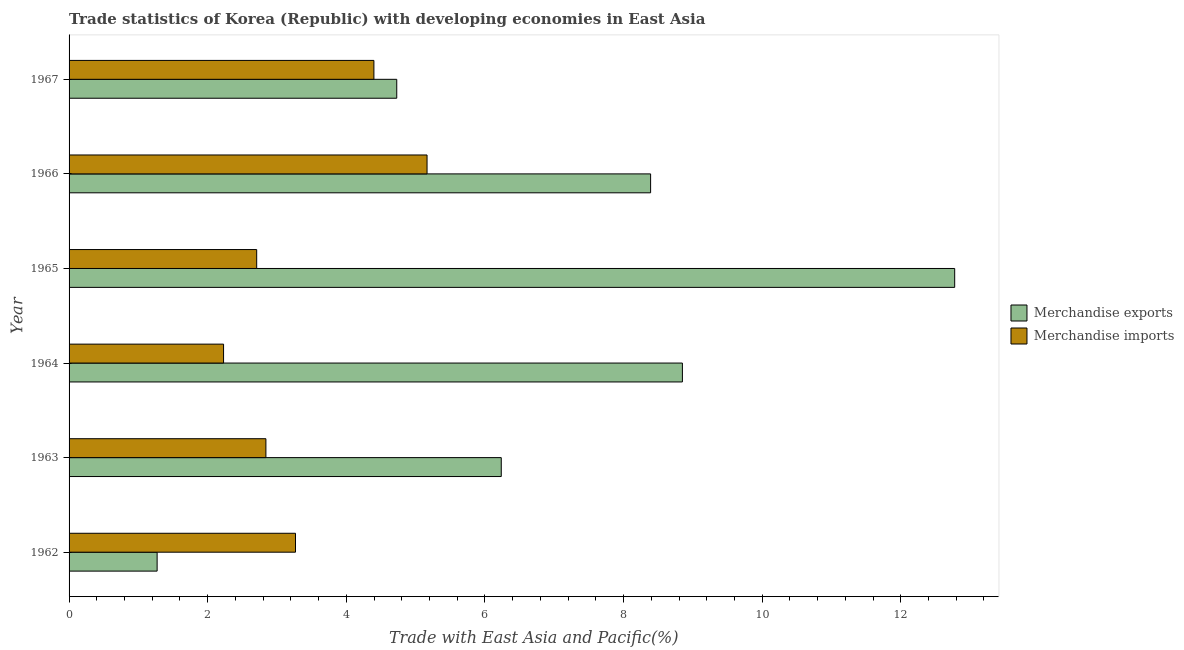How many different coloured bars are there?
Keep it short and to the point. 2. How many groups of bars are there?
Provide a succinct answer. 6. Are the number of bars per tick equal to the number of legend labels?
Offer a very short reply. Yes. Are the number of bars on each tick of the Y-axis equal?
Provide a short and direct response. Yes. What is the label of the 1st group of bars from the top?
Ensure brevity in your answer.  1967. What is the merchandise imports in 1962?
Provide a short and direct response. 3.27. Across all years, what is the maximum merchandise exports?
Offer a terse response. 12.78. Across all years, what is the minimum merchandise imports?
Provide a succinct answer. 2.23. In which year was the merchandise exports maximum?
Make the answer very short. 1965. In which year was the merchandise exports minimum?
Your answer should be compact. 1962. What is the total merchandise exports in the graph?
Provide a short and direct response. 42.25. What is the difference between the merchandise imports in 1962 and that in 1963?
Keep it short and to the point. 0.43. What is the difference between the merchandise imports in 1967 and the merchandise exports in 1963?
Provide a short and direct response. -1.84. What is the average merchandise exports per year?
Ensure brevity in your answer.  7.04. In the year 1965, what is the difference between the merchandise imports and merchandise exports?
Ensure brevity in your answer.  -10.07. What is the ratio of the merchandise imports in 1964 to that in 1965?
Your response must be concise. 0.82. Is the merchandise exports in 1963 less than that in 1964?
Your response must be concise. Yes. What is the difference between the highest and the second highest merchandise imports?
Your response must be concise. 0.77. What is the difference between the highest and the lowest merchandise exports?
Provide a short and direct response. 11.51. In how many years, is the merchandise exports greater than the average merchandise exports taken over all years?
Give a very brief answer. 3. What does the 1st bar from the bottom in 1967 represents?
Your answer should be compact. Merchandise exports. Are all the bars in the graph horizontal?
Provide a short and direct response. Yes. What is the difference between two consecutive major ticks on the X-axis?
Make the answer very short. 2. Are the values on the major ticks of X-axis written in scientific E-notation?
Keep it short and to the point. No. Does the graph contain grids?
Ensure brevity in your answer.  No. Where does the legend appear in the graph?
Provide a succinct answer. Center right. How are the legend labels stacked?
Your answer should be compact. Vertical. What is the title of the graph?
Offer a terse response. Trade statistics of Korea (Republic) with developing economies in East Asia. Does "Excluding technical cooperation" appear as one of the legend labels in the graph?
Your answer should be compact. No. What is the label or title of the X-axis?
Make the answer very short. Trade with East Asia and Pacific(%). What is the label or title of the Y-axis?
Your response must be concise. Year. What is the Trade with East Asia and Pacific(%) of Merchandise exports in 1962?
Your answer should be compact. 1.27. What is the Trade with East Asia and Pacific(%) in Merchandise imports in 1962?
Your response must be concise. 3.27. What is the Trade with East Asia and Pacific(%) in Merchandise exports in 1963?
Offer a very short reply. 6.24. What is the Trade with East Asia and Pacific(%) in Merchandise imports in 1963?
Offer a terse response. 2.84. What is the Trade with East Asia and Pacific(%) of Merchandise exports in 1964?
Keep it short and to the point. 8.85. What is the Trade with East Asia and Pacific(%) in Merchandise imports in 1964?
Give a very brief answer. 2.23. What is the Trade with East Asia and Pacific(%) in Merchandise exports in 1965?
Give a very brief answer. 12.78. What is the Trade with East Asia and Pacific(%) in Merchandise imports in 1965?
Keep it short and to the point. 2.71. What is the Trade with East Asia and Pacific(%) of Merchandise exports in 1966?
Keep it short and to the point. 8.39. What is the Trade with East Asia and Pacific(%) in Merchandise imports in 1966?
Offer a terse response. 5.16. What is the Trade with East Asia and Pacific(%) in Merchandise exports in 1967?
Offer a very short reply. 4.73. What is the Trade with East Asia and Pacific(%) in Merchandise imports in 1967?
Your answer should be compact. 4.4. Across all years, what is the maximum Trade with East Asia and Pacific(%) in Merchandise exports?
Ensure brevity in your answer.  12.78. Across all years, what is the maximum Trade with East Asia and Pacific(%) in Merchandise imports?
Offer a terse response. 5.16. Across all years, what is the minimum Trade with East Asia and Pacific(%) in Merchandise exports?
Offer a very short reply. 1.27. Across all years, what is the minimum Trade with East Asia and Pacific(%) in Merchandise imports?
Offer a terse response. 2.23. What is the total Trade with East Asia and Pacific(%) of Merchandise exports in the graph?
Offer a terse response. 42.25. What is the total Trade with East Asia and Pacific(%) of Merchandise imports in the graph?
Offer a terse response. 20.61. What is the difference between the Trade with East Asia and Pacific(%) in Merchandise exports in 1962 and that in 1963?
Your answer should be compact. -4.97. What is the difference between the Trade with East Asia and Pacific(%) in Merchandise imports in 1962 and that in 1963?
Give a very brief answer. 0.43. What is the difference between the Trade with East Asia and Pacific(%) of Merchandise exports in 1962 and that in 1964?
Give a very brief answer. -7.58. What is the difference between the Trade with East Asia and Pacific(%) in Merchandise imports in 1962 and that in 1964?
Provide a succinct answer. 1.04. What is the difference between the Trade with East Asia and Pacific(%) of Merchandise exports in 1962 and that in 1965?
Make the answer very short. -11.51. What is the difference between the Trade with East Asia and Pacific(%) in Merchandise imports in 1962 and that in 1965?
Provide a short and direct response. 0.56. What is the difference between the Trade with East Asia and Pacific(%) of Merchandise exports in 1962 and that in 1966?
Your response must be concise. -7.12. What is the difference between the Trade with East Asia and Pacific(%) of Merchandise imports in 1962 and that in 1966?
Offer a very short reply. -1.9. What is the difference between the Trade with East Asia and Pacific(%) in Merchandise exports in 1962 and that in 1967?
Your answer should be very brief. -3.46. What is the difference between the Trade with East Asia and Pacific(%) in Merchandise imports in 1962 and that in 1967?
Provide a succinct answer. -1.13. What is the difference between the Trade with East Asia and Pacific(%) of Merchandise exports in 1963 and that in 1964?
Your answer should be very brief. -2.61. What is the difference between the Trade with East Asia and Pacific(%) of Merchandise imports in 1963 and that in 1964?
Your answer should be very brief. 0.61. What is the difference between the Trade with East Asia and Pacific(%) of Merchandise exports in 1963 and that in 1965?
Your response must be concise. -6.54. What is the difference between the Trade with East Asia and Pacific(%) in Merchandise imports in 1963 and that in 1965?
Provide a short and direct response. 0.13. What is the difference between the Trade with East Asia and Pacific(%) of Merchandise exports in 1963 and that in 1966?
Your response must be concise. -2.15. What is the difference between the Trade with East Asia and Pacific(%) in Merchandise imports in 1963 and that in 1966?
Give a very brief answer. -2.32. What is the difference between the Trade with East Asia and Pacific(%) in Merchandise exports in 1963 and that in 1967?
Offer a terse response. 1.51. What is the difference between the Trade with East Asia and Pacific(%) of Merchandise imports in 1963 and that in 1967?
Ensure brevity in your answer.  -1.56. What is the difference between the Trade with East Asia and Pacific(%) of Merchandise exports in 1964 and that in 1965?
Provide a succinct answer. -3.93. What is the difference between the Trade with East Asia and Pacific(%) in Merchandise imports in 1964 and that in 1965?
Provide a short and direct response. -0.48. What is the difference between the Trade with East Asia and Pacific(%) of Merchandise exports in 1964 and that in 1966?
Give a very brief answer. 0.46. What is the difference between the Trade with East Asia and Pacific(%) of Merchandise imports in 1964 and that in 1966?
Provide a succinct answer. -2.94. What is the difference between the Trade with East Asia and Pacific(%) in Merchandise exports in 1964 and that in 1967?
Provide a short and direct response. 4.12. What is the difference between the Trade with East Asia and Pacific(%) of Merchandise imports in 1964 and that in 1967?
Your answer should be compact. -2.17. What is the difference between the Trade with East Asia and Pacific(%) of Merchandise exports in 1965 and that in 1966?
Ensure brevity in your answer.  4.39. What is the difference between the Trade with East Asia and Pacific(%) of Merchandise imports in 1965 and that in 1966?
Make the answer very short. -2.46. What is the difference between the Trade with East Asia and Pacific(%) in Merchandise exports in 1965 and that in 1967?
Give a very brief answer. 8.05. What is the difference between the Trade with East Asia and Pacific(%) of Merchandise imports in 1965 and that in 1967?
Offer a very short reply. -1.69. What is the difference between the Trade with East Asia and Pacific(%) of Merchandise exports in 1966 and that in 1967?
Provide a short and direct response. 3.66. What is the difference between the Trade with East Asia and Pacific(%) in Merchandise imports in 1966 and that in 1967?
Your answer should be compact. 0.77. What is the difference between the Trade with East Asia and Pacific(%) of Merchandise exports in 1962 and the Trade with East Asia and Pacific(%) of Merchandise imports in 1963?
Keep it short and to the point. -1.57. What is the difference between the Trade with East Asia and Pacific(%) in Merchandise exports in 1962 and the Trade with East Asia and Pacific(%) in Merchandise imports in 1964?
Your answer should be compact. -0.96. What is the difference between the Trade with East Asia and Pacific(%) of Merchandise exports in 1962 and the Trade with East Asia and Pacific(%) of Merchandise imports in 1965?
Provide a succinct answer. -1.44. What is the difference between the Trade with East Asia and Pacific(%) of Merchandise exports in 1962 and the Trade with East Asia and Pacific(%) of Merchandise imports in 1966?
Your answer should be compact. -3.89. What is the difference between the Trade with East Asia and Pacific(%) of Merchandise exports in 1962 and the Trade with East Asia and Pacific(%) of Merchandise imports in 1967?
Your answer should be very brief. -3.13. What is the difference between the Trade with East Asia and Pacific(%) in Merchandise exports in 1963 and the Trade with East Asia and Pacific(%) in Merchandise imports in 1964?
Offer a terse response. 4.01. What is the difference between the Trade with East Asia and Pacific(%) of Merchandise exports in 1963 and the Trade with East Asia and Pacific(%) of Merchandise imports in 1965?
Your answer should be compact. 3.53. What is the difference between the Trade with East Asia and Pacific(%) of Merchandise exports in 1963 and the Trade with East Asia and Pacific(%) of Merchandise imports in 1966?
Give a very brief answer. 1.07. What is the difference between the Trade with East Asia and Pacific(%) in Merchandise exports in 1963 and the Trade with East Asia and Pacific(%) in Merchandise imports in 1967?
Provide a short and direct response. 1.84. What is the difference between the Trade with East Asia and Pacific(%) in Merchandise exports in 1964 and the Trade with East Asia and Pacific(%) in Merchandise imports in 1965?
Your answer should be very brief. 6.14. What is the difference between the Trade with East Asia and Pacific(%) in Merchandise exports in 1964 and the Trade with East Asia and Pacific(%) in Merchandise imports in 1966?
Provide a succinct answer. 3.68. What is the difference between the Trade with East Asia and Pacific(%) of Merchandise exports in 1964 and the Trade with East Asia and Pacific(%) of Merchandise imports in 1967?
Offer a terse response. 4.45. What is the difference between the Trade with East Asia and Pacific(%) of Merchandise exports in 1965 and the Trade with East Asia and Pacific(%) of Merchandise imports in 1966?
Provide a short and direct response. 7.61. What is the difference between the Trade with East Asia and Pacific(%) in Merchandise exports in 1965 and the Trade with East Asia and Pacific(%) in Merchandise imports in 1967?
Your response must be concise. 8.38. What is the difference between the Trade with East Asia and Pacific(%) in Merchandise exports in 1966 and the Trade with East Asia and Pacific(%) in Merchandise imports in 1967?
Ensure brevity in your answer.  3.99. What is the average Trade with East Asia and Pacific(%) of Merchandise exports per year?
Provide a short and direct response. 7.04. What is the average Trade with East Asia and Pacific(%) of Merchandise imports per year?
Offer a terse response. 3.43. In the year 1962, what is the difference between the Trade with East Asia and Pacific(%) in Merchandise exports and Trade with East Asia and Pacific(%) in Merchandise imports?
Your answer should be compact. -2. In the year 1963, what is the difference between the Trade with East Asia and Pacific(%) of Merchandise exports and Trade with East Asia and Pacific(%) of Merchandise imports?
Ensure brevity in your answer.  3.4. In the year 1964, what is the difference between the Trade with East Asia and Pacific(%) of Merchandise exports and Trade with East Asia and Pacific(%) of Merchandise imports?
Ensure brevity in your answer.  6.62. In the year 1965, what is the difference between the Trade with East Asia and Pacific(%) in Merchandise exports and Trade with East Asia and Pacific(%) in Merchandise imports?
Make the answer very short. 10.07. In the year 1966, what is the difference between the Trade with East Asia and Pacific(%) of Merchandise exports and Trade with East Asia and Pacific(%) of Merchandise imports?
Offer a terse response. 3.23. In the year 1967, what is the difference between the Trade with East Asia and Pacific(%) in Merchandise exports and Trade with East Asia and Pacific(%) in Merchandise imports?
Give a very brief answer. 0.33. What is the ratio of the Trade with East Asia and Pacific(%) of Merchandise exports in 1962 to that in 1963?
Ensure brevity in your answer.  0.2. What is the ratio of the Trade with East Asia and Pacific(%) in Merchandise imports in 1962 to that in 1963?
Give a very brief answer. 1.15. What is the ratio of the Trade with East Asia and Pacific(%) of Merchandise exports in 1962 to that in 1964?
Your answer should be very brief. 0.14. What is the ratio of the Trade with East Asia and Pacific(%) of Merchandise imports in 1962 to that in 1964?
Provide a succinct answer. 1.47. What is the ratio of the Trade with East Asia and Pacific(%) of Merchandise exports in 1962 to that in 1965?
Provide a short and direct response. 0.1. What is the ratio of the Trade with East Asia and Pacific(%) in Merchandise imports in 1962 to that in 1965?
Your answer should be very brief. 1.21. What is the ratio of the Trade with East Asia and Pacific(%) in Merchandise exports in 1962 to that in 1966?
Offer a very short reply. 0.15. What is the ratio of the Trade with East Asia and Pacific(%) in Merchandise imports in 1962 to that in 1966?
Your answer should be very brief. 0.63. What is the ratio of the Trade with East Asia and Pacific(%) in Merchandise exports in 1962 to that in 1967?
Make the answer very short. 0.27. What is the ratio of the Trade with East Asia and Pacific(%) in Merchandise imports in 1962 to that in 1967?
Provide a succinct answer. 0.74. What is the ratio of the Trade with East Asia and Pacific(%) of Merchandise exports in 1963 to that in 1964?
Your response must be concise. 0.7. What is the ratio of the Trade with East Asia and Pacific(%) of Merchandise imports in 1963 to that in 1964?
Provide a short and direct response. 1.27. What is the ratio of the Trade with East Asia and Pacific(%) of Merchandise exports in 1963 to that in 1965?
Your answer should be compact. 0.49. What is the ratio of the Trade with East Asia and Pacific(%) in Merchandise imports in 1963 to that in 1965?
Your response must be concise. 1.05. What is the ratio of the Trade with East Asia and Pacific(%) of Merchandise exports in 1963 to that in 1966?
Your answer should be very brief. 0.74. What is the ratio of the Trade with East Asia and Pacific(%) in Merchandise imports in 1963 to that in 1966?
Provide a short and direct response. 0.55. What is the ratio of the Trade with East Asia and Pacific(%) of Merchandise exports in 1963 to that in 1967?
Provide a succinct answer. 1.32. What is the ratio of the Trade with East Asia and Pacific(%) of Merchandise imports in 1963 to that in 1967?
Ensure brevity in your answer.  0.65. What is the ratio of the Trade with East Asia and Pacific(%) in Merchandise exports in 1964 to that in 1965?
Ensure brevity in your answer.  0.69. What is the ratio of the Trade with East Asia and Pacific(%) in Merchandise imports in 1964 to that in 1965?
Keep it short and to the point. 0.82. What is the ratio of the Trade with East Asia and Pacific(%) of Merchandise exports in 1964 to that in 1966?
Offer a very short reply. 1.05. What is the ratio of the Trade with East Asia and Pacific(%) in Merchandise imports in 1964 to that in 1966?
Offer a terse response. 0.43. What is the ratio of the Trade with East Asia and Pacific(%) of Merchandise exports in 1964 to that in 1967?
Offer a very short reply. 1.87. What is the ratio of the Trade with East Asia and Pacific(%) in Merchandise imports in 1964 to that in 1967?
Ensure brevity in your answer.  0.51. What is the ratio of the Trade with East Asia and Pacific(%) of Merchandise exports in 1965 to that in 1966?
Make the answer very short. 1.52. What is the ratio of the Trade with East Asia and Pacific(%) of Merchandise imports in 1965 to that in 1966?
Keep it short and to the point. 0.52. What is the ratio of the Trade with East Asia and Pacific(%) in Merchandise exports in 1965 to that in 1967?
Ensure brevity in your answer.  2.7. What is the ratio of the Trade with East Asia and Pacific(%) of Merchandise imports in 1965 to that in 1967?
Offer a very short reply. 0.62. What is the ratio of the Trade with East Asia and Pacific(%) in Merchandise exports in 1966 to that in 1967?
Your answer should be compact. 1.77. What is the ratio of the Trade with East Asia and Pacific(%) of Merchandise imports in 1966 to that in 1967?
Keep it short and to the point. 1.17. What is the difference between the highest and the second highest Trade with East Asia and Pacific(%) in Merchandise exports?
Keep it short and to the point. 3.93. What is the difference between the highest and the second highest Trade with East Asia and Pacific(%) of Merchandise imports?
Your response must be concise. 0.77. What is the difference between the highest and the lowest Trade with East Asia and Pacific(%) in Merchandise exports?
Keep it short and to the point. 11.51. What is the difference between the highest and the lowest Trade with East Asia and Pacific(%) of Merchandise imports?
Offer a very short reply. 2.94. 